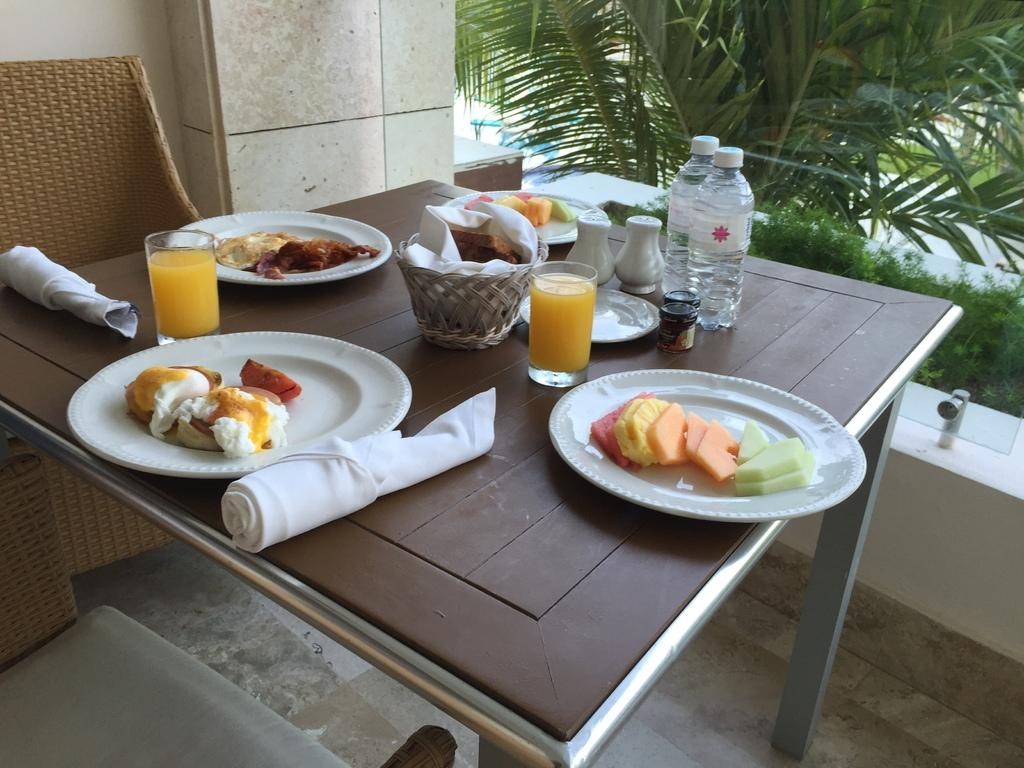What type of objects are on the plates in the image? The facts do not specify the type of food on the plates. What can be found in the glasses in the image? The facts do not specify the contents of the glasses. What type of bottles are in the image? The facts do not specify the type of bottles. Where are all these objects located? All of these objects are on a table in the image. What is visible in the background of the image? There is a tree visible in the image. What type of seating is present in the image? There is a chair in the image. How many legs can be seen on the spoon in the image? There is no spoon present in the image, so it is not possible to determine the number of legs on a spoon. 